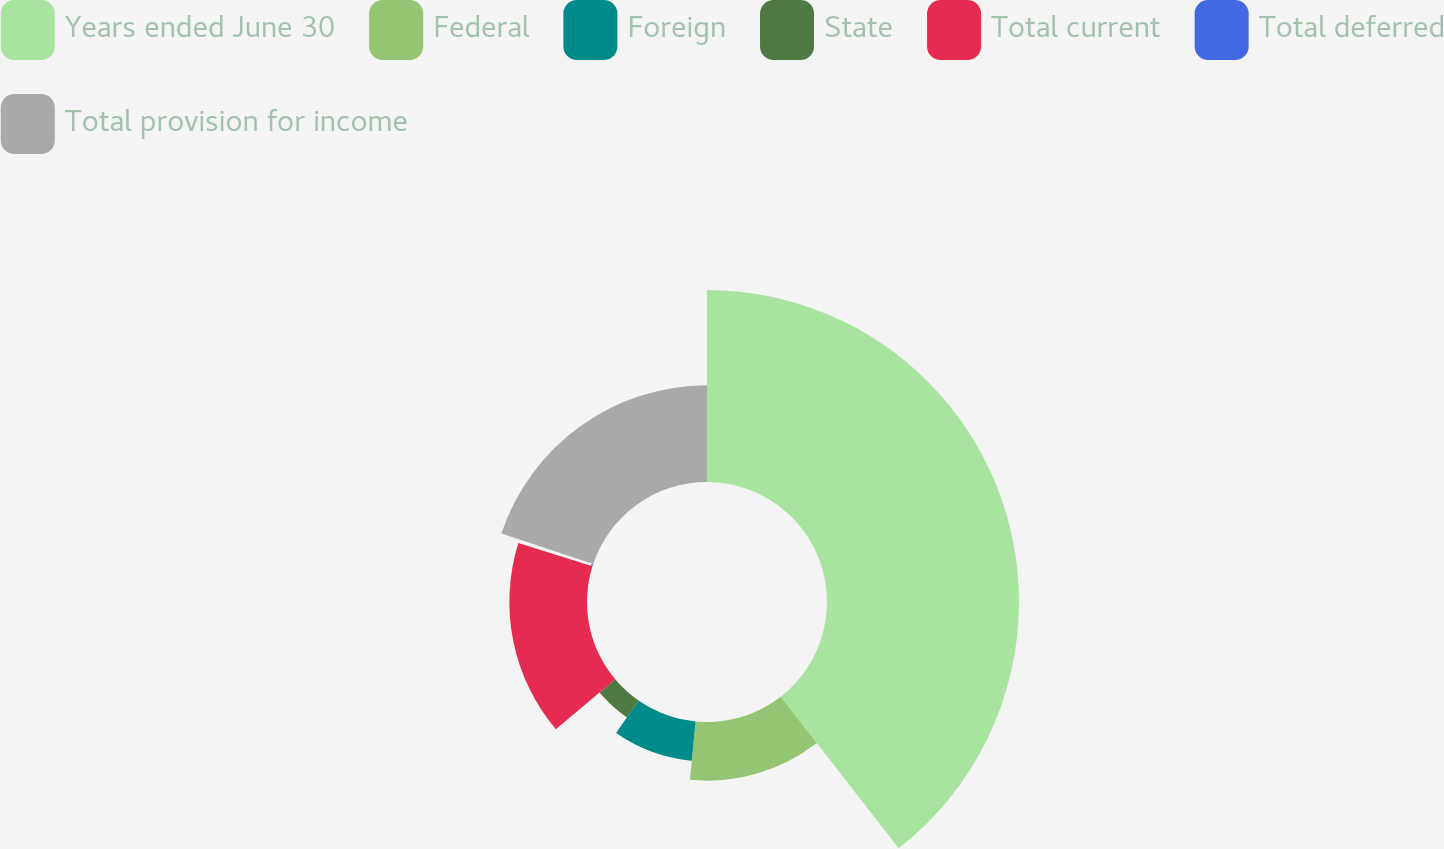Convert chart. <chart><loc_0><loc_0><loc_500><loc_500><pie_chart><fcel>Years ended June 30<fcel>Federal<fcel>Foreign<fcel>State<fcel>Total current<fcel>Total deferred<fcel>Total provision for income<nl><fcel>39.47%<fcel>12.05%<fcel>8.13%<fcel>4.21%<fcel>15.96%<fcel>0.3%<fcel>19.88%<nl></chart> 